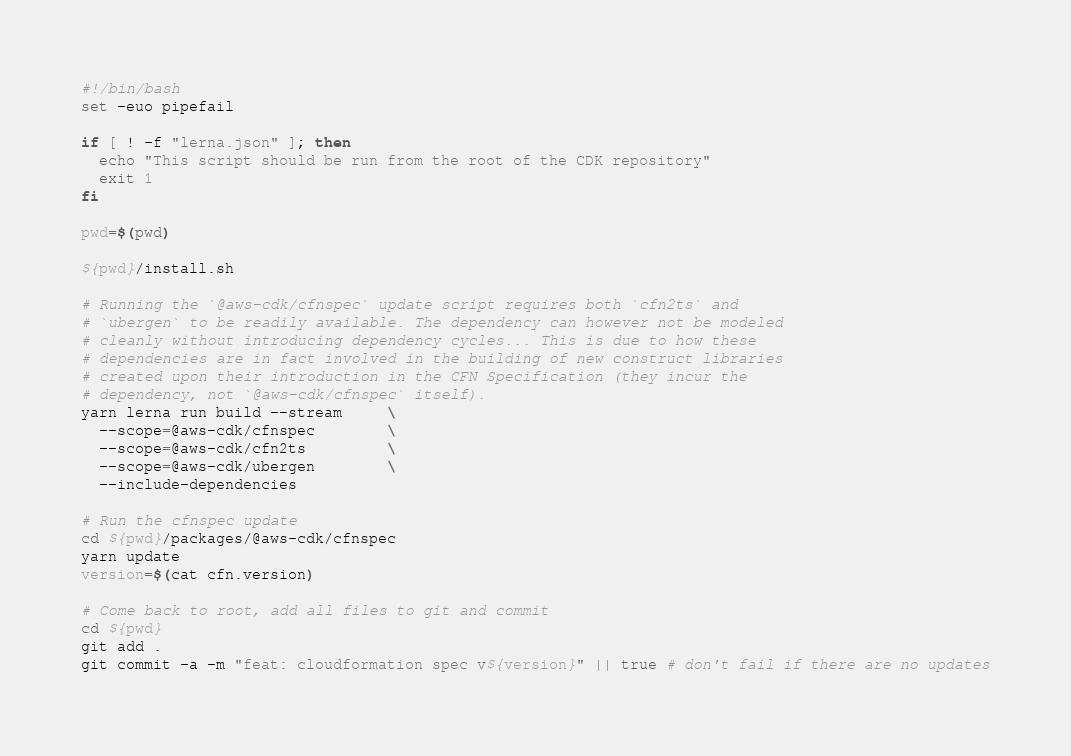Convert code to text. <code><loc_0><loc_0><loc_500><loc_500><_Bash_>#!/bin/bash
set -euo pipefail

if [ ! -f "lerna.json" ]; then
  echo "This script should be run from the root of the CDK repository"
  exit 1
fi

pwd=$(pwd)

${pwd}/install.sh

# Running the `@aws-cdk/cfnspec` update script requires both `cfn2ts` and
# `ubergen` to be readily available. The dependency can however not be modeled
# cleanly without introducing dependency cycles... This is due to how these
# dependencies are in fact involved in the building of new construct libraries
# created upon their introduction in the CFN Specification (they incur the
# dependency, not `@aws-cdk/cfnspec` itself).
yarn lerna run build --stream     \
  --scope=@aws-cdk/cfnspec        \
  --scope=@aws-cdk/cfn2ts         \
  --scope=@aws-cdk/ubergen        \
  --include-dependencies

# Run the cfnspec update
cd ${pwd}/packages/@aws-cdk/cfnspec
yarn update
version=$(cat cfn.version)

# Come back to root, add all files to git and commit
cd ${pwd}
git add .
git commit -a -m "feat: cloudformation spec v${version}" || true # don't fail if there are no updates
</code> 